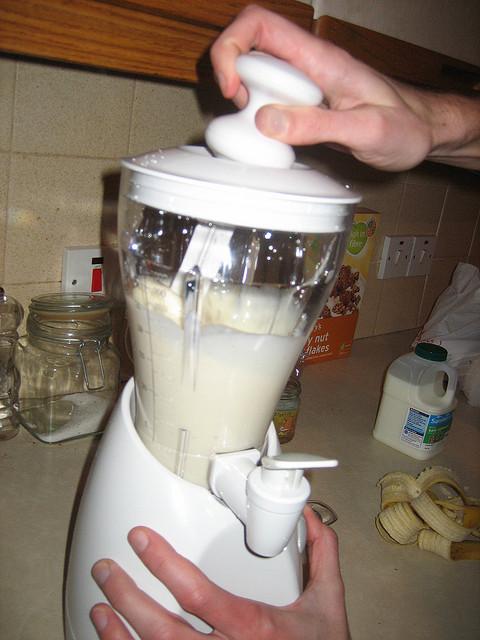What is in the blender?
Concise answer only. Milk. What liquid is in the jug with the blue label?
Short answer required. Milk. Is someone trying to make a milkshake?
Quick response, please. Yes. What kind of motion is the machine doing?
Concise answer only. Blending. 